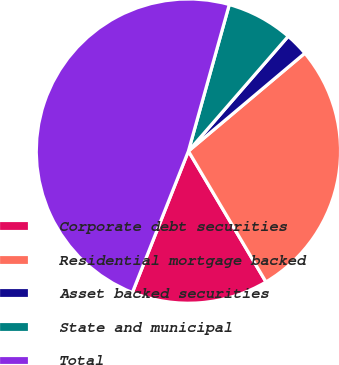Convert chart. <chart><loc_0><loc_0><loc_500><loc_500><pie_chart><fcel>Corporate debt securities<fcel>Residential mortgage backed<fcel>Asset backed securities<fcel>State and municipal<fcel>Total<nl><fcel>14.52%<fcel>27.62%<fcel>2.48%<fcel>7.06%<fcel>48.33%<nl></chart> 